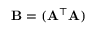Convert formula to latex. <formula><loc_0><loc_0><loc_500><loc_500>B = ( A ^ { \top } A )</formula> 